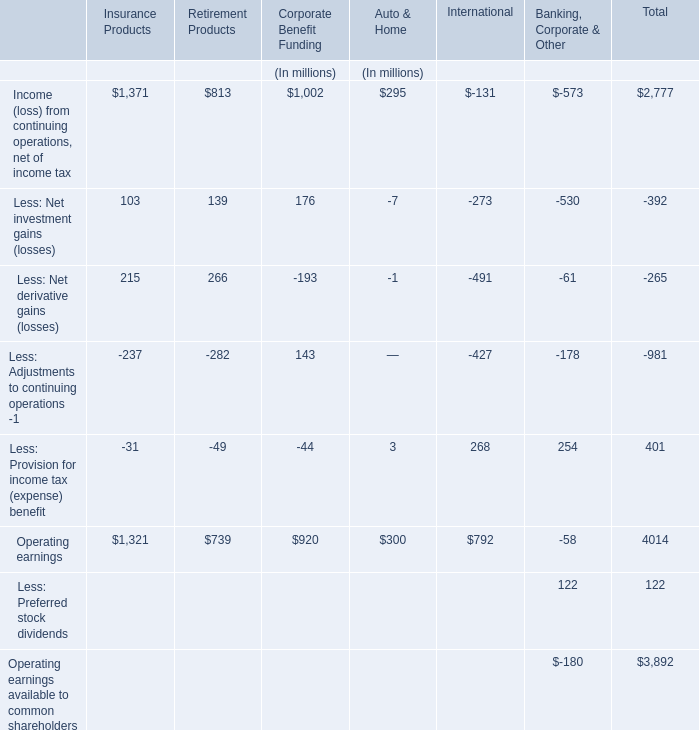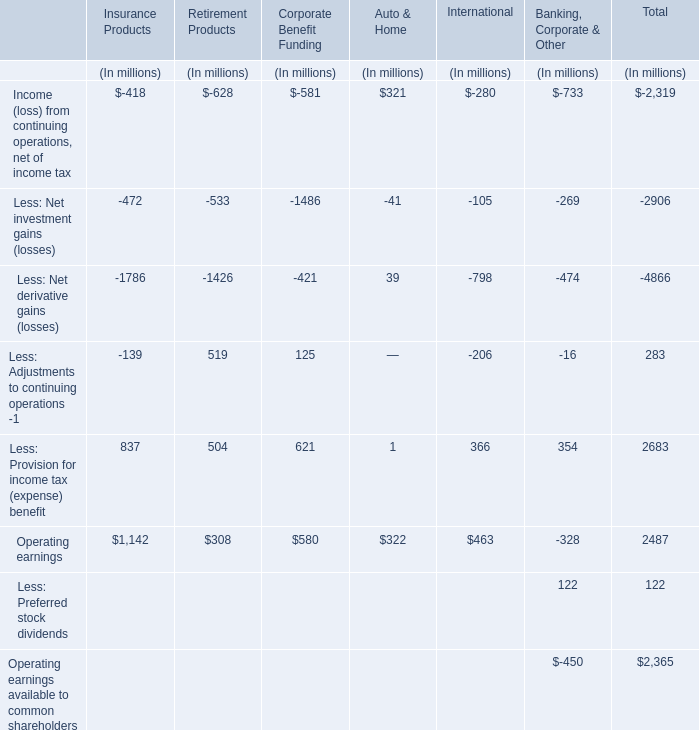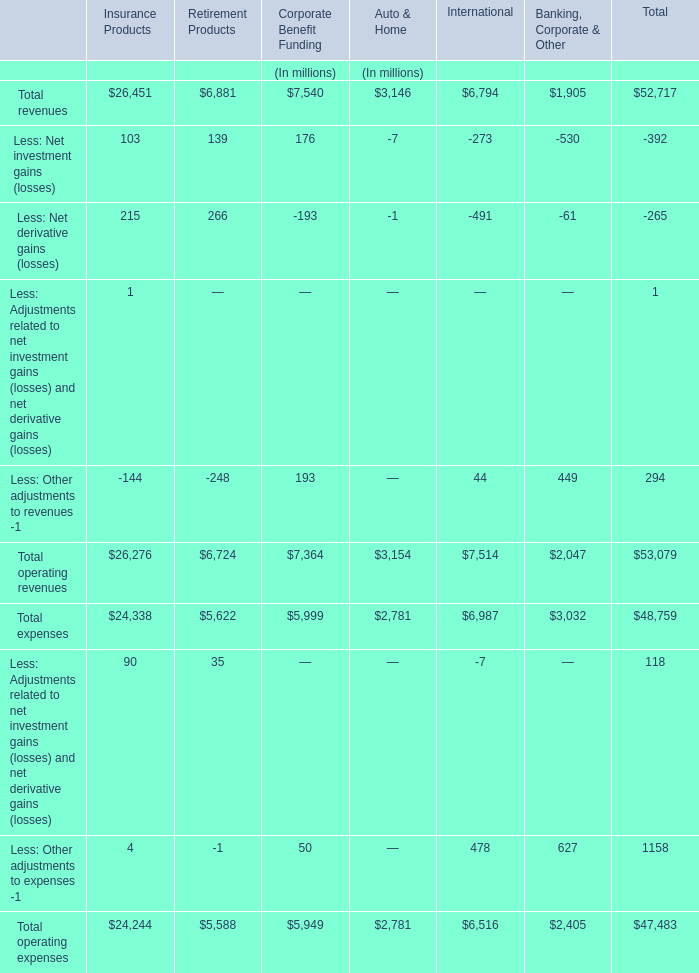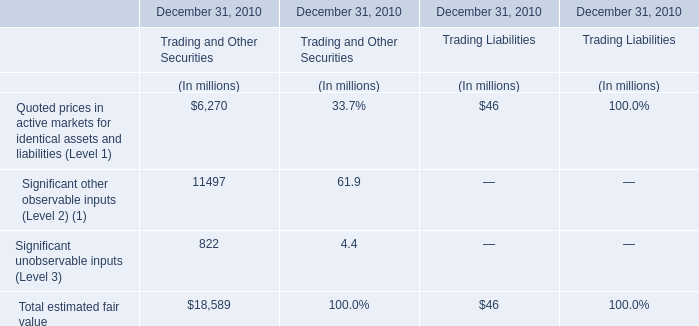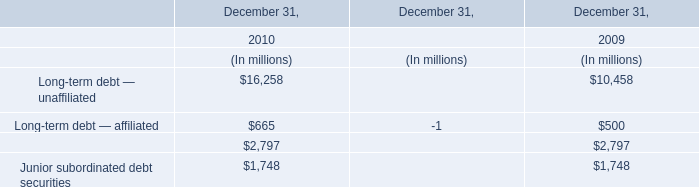What is the proportion of all operating revenues that are greater than -200 to the total amount of operating revenue, in international? (in %) 
Computations: ((6794 + 44) / (((6794 - 273) - 491) + 44))
Answer: 1.12578. 